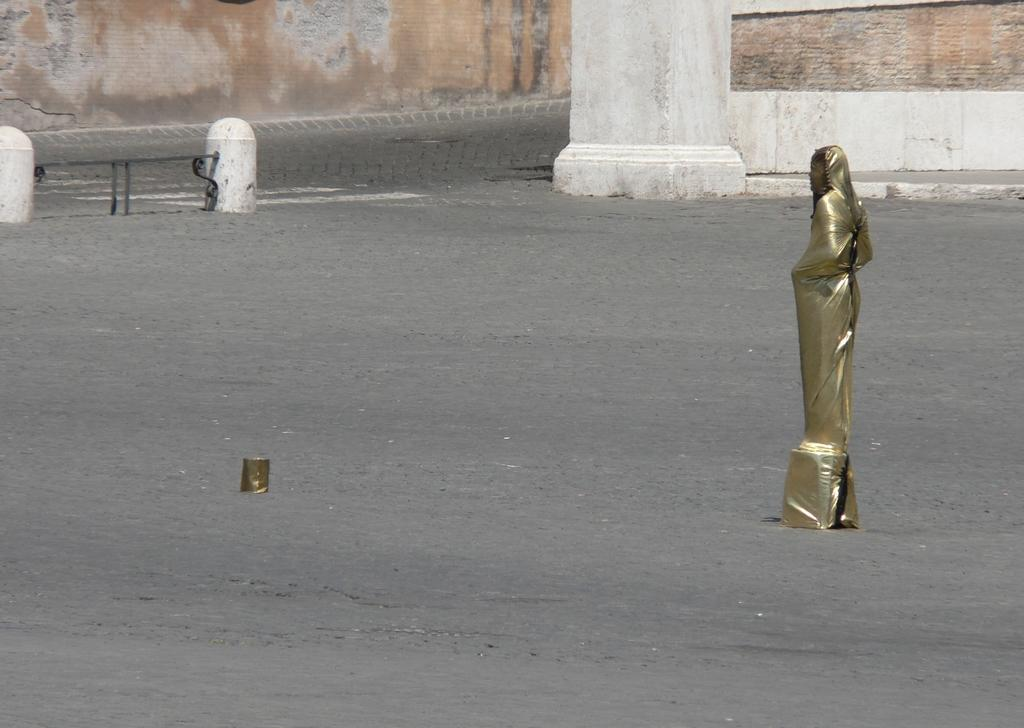What is the main subject in the image? There is a statue in the image. What other architectural feature can be seen in the image? There is a pillar in the image. What else is present in the image besides the statue and pillar? There are objects in the image. What can be seen in the background of the image? There is a wall in the background of the image. How many boats are visible in the image? There are no boats present in the image. What type of furniture is being used by the statue in the image? The statue is not using any furniture, as it is a stationary object in the image. 